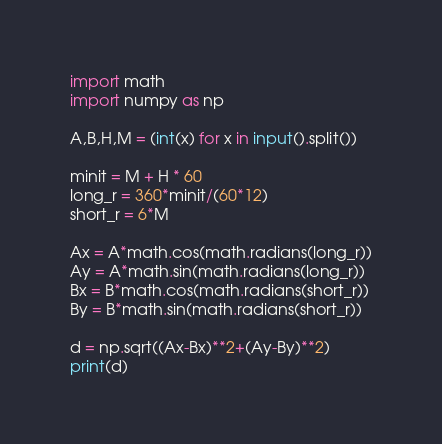Convert code to text. <code><loc_0><loc_0><loc_500><loc_500><_Python_>import math
import numpy as np

A,B,H,M = (int(x) for x in input().split())

minit = M + H * 60
long_r = 360*minit/(60*12)
short_r = 6*M

Ax = A*math.cos(math.radians(long_r))
Ay = A*math.sin(math.radians(long_r))
Bx = B*math.cos(math.radians(short_r))
By = B*math.sin(math.radians(short_r))

d = np.sqrt((Ax-Bx)**2+(Ay-By)**2)
print(d)</code> 